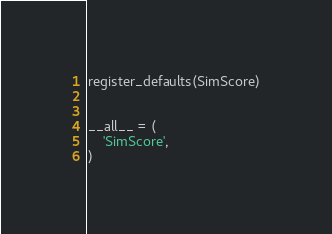Convert code to text. <code><loc_0><loc_0><loc_500><loc_500><_Python_>

register_defaults(SimScore)


__all__ = (
    'SimScore',
)
</code> 